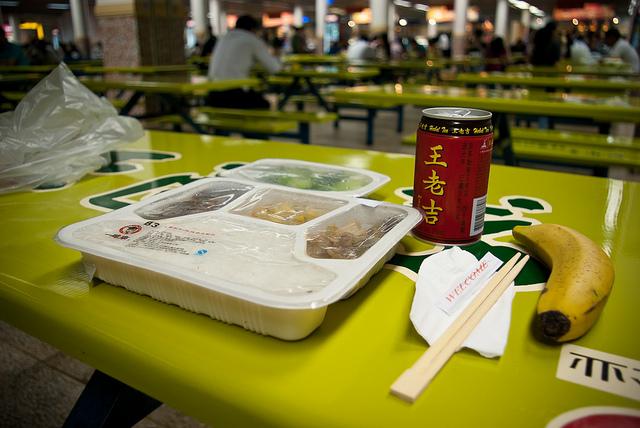What brand of soda is served at this restaurant?
Answer briefly. Coke. Could you heat this meal in a microwave?
Keep it brief. Yes. Do you need a chopstick?
Quick response, please. Yes. How many desserts are in the picture?
Give a very brief answer. 1. What color is the table?
Quick response, please. Green. Is there a Chinese soda on the table?
Concise answer only. Yes. What items are on the table?
Answer briefly. Food. 